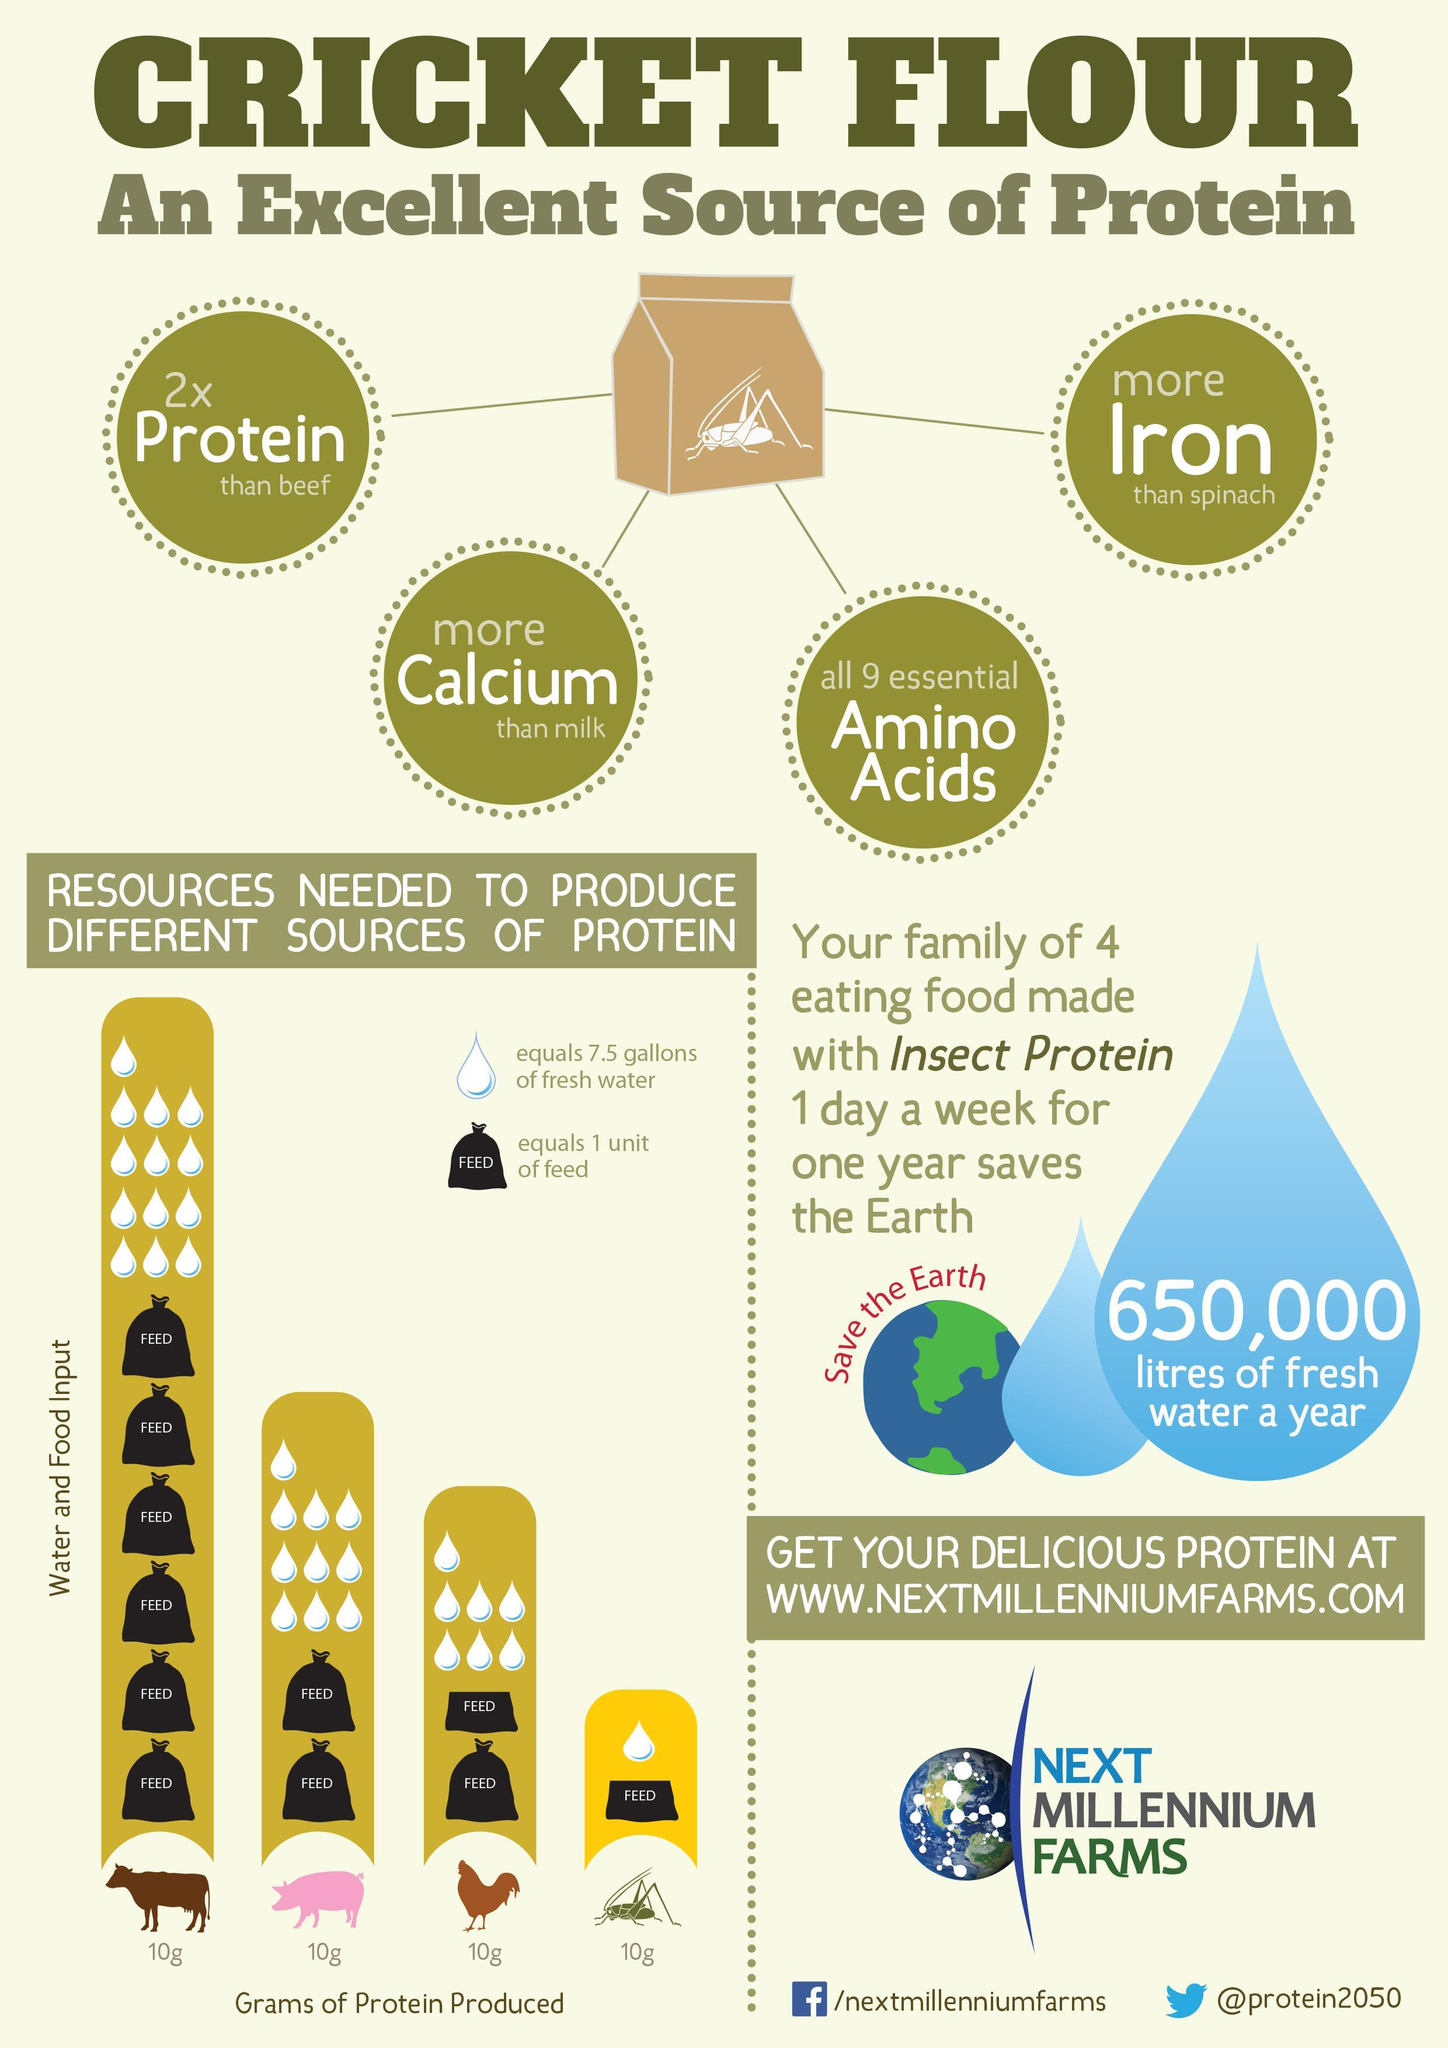what is the amount of water in gallons needed to produce 10g beef protein?
Answer the question with a short phrase. 97.5 which animal needed more units of food to produce 10g protein - cattle or insects? cattle which animal needed more units of food to produce 10g protein - pigs or roosters? pigs what is the amount of water in gallons needed to produce 10g insect protein? 7.5 what is the amount of water in gallons needed to produce 10 g protein in rooster? 52.5 how many units of food needed to produce 10g protein in pig? 2 what is the amount of water in gallons needed to produce 10g protein in pig? 75 what are the essential nutrients other than protein from cricket flour given in this infographic? calcium, amino acids, iron 